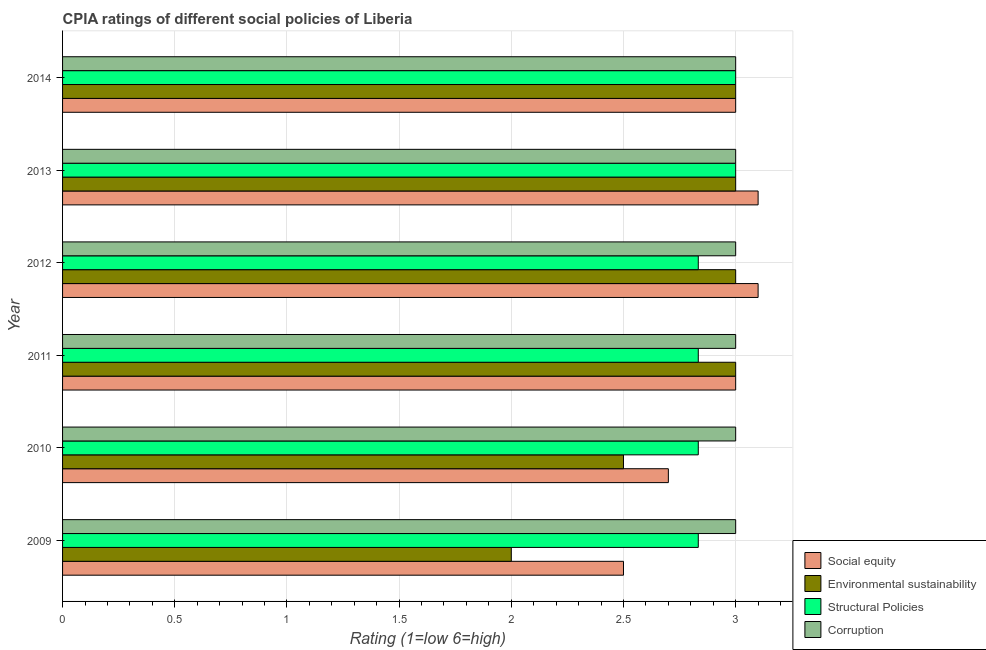How many different coloured bars are there?
Make the answer very short. 4. How many groups of bars are there?
Offer a terse response. 6. Are the number of bars on each tick of the Y-axis equal?
Your answer should be very brief. Yes. How many bars are there on the 6th tick from the top?
Offer a very short reply. 4. In how many cases, is the number of bars for a given year not equal to the number of legend labels?
Ensure brevity in your answer.  0. Across all years, what is the maximum cpia rating of corruption?
Give a very brief answer. 3. Across all years, what is the minimum cpia rating of social equity?
Make the answer very short. 2.5. In which year was the cpia rating of structural policies maximum?
Your answer should be compact. 2013. In which year was the cpia rating of structural policies minimum?
Your answer should be compact. 2009. What is the total cpia rating of structural policies in the graph?
Your response must be concise. 17.33. What is the difference between the cpia rating of structural policies in 2010 and that in 2012?
Provide a succinct answer. 0. What is the difference between the cpia rating of structural policies in 2009 and the cpia rating of corruption in 2011?
Provide a short and direct response. -0.17. What is the average cpia rating of structural policies per year?
Offer a terse response. 2.89. In how many years, is the cpia rating of structural policies greater than 1.5 ?
Provide a short and direct response. 6. Is the cpia rating of corruption in 2010 less than that in 2013?
Your answer should be compact. No. In how many years, is the cpia rating of environmental sustainability greater than the average cpia rating of environmental sustainability taken over all years?
Make the answer very short. 4. Is it the case that in every year, the sum of the cpia rating of social equity and cpia rating of corruption is greater than the sum of cpia rating of structural policies and cpia rating of environmental sustainability?
Your response must be concise. No. What does the 3rd bar from the top in 2011 represents?
Ensure brevity in your answer.  Environmental sustainability. What does the 4th bar from the bottom in 2010 represents?
Ensure brevity in your answer.  Corruption. Is it the case that in every year, the sum of the cpia rating of social equity and cpia rating of environmental sustainability is greater than the cpia rating of structural policies?
Make the answer very short. Yes. How many bars are there?
Keep it short and to the point. 24. What is the difference between two consecutive major ticks on the X-axis?
Offer a very short reply. 0.5. How many legend labels are there?
Your response must be concise. 4. What is the title of the graph?
Your response must be concise. CPIA ratings of different social policies of Liberia. Does "International Monetary Fund" appear as one of the legend labels in the graph?
Your response must be concise. No. What is the Rating (1=low 6=high) of Social equity in 2009?
Provide a short and direct response. 2.5. What is the Rating (1=low 6=high) of Structural Policies in 2009?
Your response must be concise. 2.83. What is the Rating (1=low 6=high) in Social equity in 2010?
Keep it short and to the point. 2.7. What is the Rating (1=low 6=high) of Environmental sustainability in 2010?
Provide a short and direct response. 2.5. What is the Rating (1=low 6=high) of Structural Policies in 2010?
Your response must be concise. 2.83. What is the Rating (1=low 6=high) in Corruption in 2010?
Offer a very short reply. 3. What is the Rating (1=low 6=high) of Environmental sustainability in 2011?
Your response must be concise. 3. What is the Rating (1=low 6=high) of Structural Policies in 2011?
Offer a very short reply. 2.83. What is the Rating (1=low 6=high) in Corruption in 2011?
Keep it short and to the point. 3. What is the Rating (1=low 6=high) of Environmental sustainability in 2012?
Make the answer very short. 3. What is the Rating (1=low 6=high) in Structural Policies in 2012?
Provide a short and direct response. 2.83. What is the Rating (1=low 6=high) in Environmental sustainability in 2013?
Offer a very short reply. 3. What is the Rating (1=low 6=high) in Corruption in 2013?
Ensure brevity in your answer.  3. What is the Rating (1=low 6=high) of Environmental sustainability in 2014?
Give a very brief answer. 3. What is the Rating (1=low 6=high) in Structural Policies in 2014?
Offer a terse response. 3. What is the Rating (1=low 6=high) of Corruption in 2014?
Ensure brevity in your answer.  3. Across all years, what is the maximum Rating (1=low 6=high) in Social equity?
Make the answer very short. 3.1. Across all years, what is the maximum Rating (1=low 6=high) in Structural Policies?
Keep it short and to the point. 3. Across all years, what is the maximum Rating (1=low 6=high) of Corruption?
Give a very brief answer. 3. Across all years, what is the minimum Rating (1=low 6=high) of Social equity?
Make the answer very short. 2.5. Across all years, what is the minimum Rating (1=low 6=high) in Structural Policies?
Provide a short and direct response. 2.83. What is the total Rating (1=low 6=high) in Social equity in the graph?
Give a very brief answer. 17.4. What is the total Rating (1=low 6=high) of Structural Policies in the graph?
Give a very brief answer. 17.33. What is the total Rating (1=low 6=high) of Corruption in the graph?
Your answer should be compact. 18. What is the difference between the Rating (1=low 6=high) of Structural Policies in 2009 and that in 2010?
Your answer should be compact. 0. What is the difference between the Rating (1=low 6=high) in Corruption in 2009 and that in 2010?
Your response must be concise. 0. What is the difference between the Rating (1=low 6=high) of Social equity in 2009 and that in 2011?
Offer a terse response. -0.5. What is the difference between the Rating (1=low 6=high) of Structural Policies in 2009 and that in 2011?
Provide a succinct answer. 0. What is the difference between the Rating (1=low 6=high) in Corruption in 2009 and that in 2011?
Give a very brief answer. 0. What is the difference between the Rating (1=low 6=high) in Social equity in 2009 and that in 2012?
Provide a succinct answer. -0.6. What is the difference between the Rating (1=low 6=high) in Social equity in 2009 and that in 2013?
Offer a very short reply. -0.6. What is the difference between the Rating (1=low 6=high) of Environmental sustainability in 2009 and that in 2013?
Your answer should be compact. -1. What is the difference between the Rating (1=low 6=high) in Corruption in 2009 and that in 2014?
Make the answer very short. 0. What is the difference between the Rating (1=low 6=high) of Environmental sustainability in 2010 and that in 2011?
Keep it short and to the point. -0.5. What is the difference between the Rating (1=low 6=high) in Environmental sustainability in 2010 and that in 2012?
Offer a terse response. -0.5. What is the difference between the Rating (1=low 6=high) in Environmental sustainability in 2010 and that in 2013?
Keep it short and to the point. -0.5. What is the difference between the Rating (1=low 6=high) in Structural Policies in 2010 and that in 2013?
Your answer should be compact. -0.17. What is the difference between the Rating (1=low 6=high) of Corruption in 2010 and that in 2013?
Offer a terse response. 0. What is the difference between the Rating (1=low 6=high) of Environmental sustainability in 2010 and that in 2014?
Your answer should be compact. -0.5. What is the difference between the Rating (1=low 6=high) in Structural Policies in 2010 and that in 2014?
Provide a short and direct response. -0.17. What is the difference between the Rating (1=low 6=high) of Social equity in 2011 and that in 2012?
Give a very brief answer. -0.1. What is the difference between the Rating (1=low 6=high) in Environmental sustainability in 2011 and that in 2012?
Give a very brief answer. 0. What is the difference between the Rating (1=low 6=high) of Structural Policies in 2011 and that in 2012?
Provide a succinct answer. 0. What is the difference between the Rating (1=low 6=high) in Social equity in 2011 and that in 2013?
Offer a very short reply. -0.1. What is the difference between the Rating (1=low 6=high) in Environmental sustainability in 2011 and that in 2013?
Give a very brief answer. 0. What is the difference between the Rating (1=low 6=high) in Corruption in 2011 and that in 2013?
Your answer should be very brief. 0. What is the difference between the Rating (1=low 6=high) of Environmental sustainability in 2011 and that in 2014?
Your answer should be very brief. 0. What is the difference between the Rating (1=low 6=high) of Corruption in 2011 and that in 2014?
Give a very brief answer. 0. What is the difference between the Rating (1=low 6=high) in Environmental sustainability in 2012 and that in 2013?
Provide a short and direct response. 0. What is the difference between the Rating (1=low 6=high) of Structural Policies in 2012 and that in 2013?
Your answer should be very brief. -0.17. What is the difference between the Rating (1=low 6=high) in Social equity in 2012 and that in 2014?
Provide a short and direct response. 0.1. What is the difference between the Rating (1=low 6=high) in Environmental sustainability in 2012 and that in 2014?
Provide a short and direct response. 0. What is the difference between the Rating (1=low 6=high) of Structural Policies in 2013 and that in 2014?
Offer a very short reply. 0. What is the difference between the Rating (1=low 6=high) of Corruption in 2013 and that in 2014?
Your answer should be compact. 0. What is the difference between the Rating (1=low 6=high) in Social equity in 2009 and the Rating (1=low 6=high) in Environmental sustainability in 2010?
Keep it short and to the point. 0. What is the difference between the Rating (1=low 6=high) in Social equity in 2009 and the Rating (1=low 6=high) in Structural Policies in 2010?
Provide a short and direct response. -0.33. What is the difference between the Rating (1=low 6=high) of Environmental sustainability in 2009 and the Rating (1=low 6=high) of Structural Policies in 2010?
Your answer should be very brief. -0.83. What is the difference between the Rating (1=low 6=high) in Environmental sustainability in 2009 and the Rating (1=low 6=high) in Corruption in 2010?
Make the answer very short. -1. What is the difference between the Rating (1=low 6=high) of Structural Policies in 2009 and the Rating (1=low 6=high) of Corruption in 2010?
Make the answer very short. -0.17. What is the difference between the Rating (1=low 6=high) of Environmental sustainability in 2009 and the Rating (1=low 6=high) of Corruption in 2011?
Keep it short and to the point. -1. What is the difference between the Rating (1=low 6=high) in Social equity in 2009 and the Rating (1=low 6=high) in Structural Policies in 2012?
Make the answer very short. -0.33. What is the difference between the Rating (1=low 6=high) of Structural Policies in 2009 and the Rating (1=low 6=high) of Corruption in 2012?
Give a very brief answer. -0.17. What is the difference between the Rating (1=low 6=high) of Social equity in 2009 and the Rating (1=low 6=high) of Environmental sustainability in 2013?
Ensure brevity in your answer.  -0.5. What is the difference between the Rating (1=low 6=high) in Social equity in 2009 and the Rating (1=low 6=high) in Structural Policies in 2013?
Offer a very short reply. -0.5. What is the difference between the Rating (1=low 6=high) of Environmental sustainability in 2009 and the Rating (1=low 6=high) of Structural Policies in 2013?
Provide a short and direct response. -1. What is the difference between the Rating (1=low 6=high) of Social equity in 2009 and the Rating (1=low 6=high) of Environmental sustainability in 2014?
Keep it short and to the point. -0.5. What is the difference between the Rating (1=low 6=high) in Environmental sustainability in 2009 and the Rating (1=low 6=high) in Structural Policies in 2014?
Make the answer very short. -1. What is the difference between the Rating (1=low 6=high) of Structural Policies in 2009 and the Rating (1=low 6=high) of Corruption in 2014?
Offer a terse response. -0.17. What is the difference between the Rating (1=low 6=high) in Social equity in 2010 and the Rating (1=low 6=high) in Environmental sustainability in 2011?
Provide a succinct answer. -0.3. What is the difference between the Rating (1=low 6=high) of Social equity in 2010 and the Rating (1=low 6=high) of Structural Policies in 2011?
Your response must be concise. -0.13. What is the difference between the Rating (1=low 6=high) in Social equity in 2010 and the Rating (1=low 6=high) in Corruption in 2011?
Offer a very short reply. -0.3. What is the difference between the Rating (1=low 6=high) in Environmental sustainability in 2010 and the Rating (1=low 6=high) in Structural Policies in 2011?
Give a very brief answer. -0.33. What is the difference between the Rating (1=low 6=high) in Social equity in 2010 and the Rating (1=low 6=high) in Environmental sustainability in 2012?
Give a very brief answer. -0.3. What is the difference between the Rating (1=low 6=high) of Social equity in 2010 and the Rating (1=low 6=high) of Structural Policies in 2012?
Make the answer very short. -0.13. What is the difference between the Rating (1=low 6=high) of Environmental sustainability in 2010 and the Rating (1=low 6=high) of Structural Policies in 2013?
Provide a succinct answer. -0.5. What is the difference between the Rating (1=low 6=high) of Social equity in 2010 and the Rating (1=low 6=high) of Environmental sustainability in 2014?
Give a very brief answer. -0.3. What is the difference between the Rating (1=low 6=high) in Social equity in 2010 and the Rating (1=low 6=high) in Structural Policies in 2014?
Provide a short and direct response. -0.3. What is the difference between the Rating (1=low 6=high) of Social equity in 2010 and the Rating (1=low 6=high) of Corruption in 2014?
Your response must be concise. -0.3. What is the difference between the Rating (1=low 6=high) in Environmental sustainability in 2010 and the Rating (1=low 6=high) in Corruption in 2014?
Offer a very short reply. -0.5. What is the difference between the Rating (1=low 6=high) in Structural Policies in 2010 and the Rating (1=low 6=high) in Corruption in 2014?
Give a very brief answer. -0.17. What is the difference between the Rating (1=low 6=high) of Social equity in 2011 and the Rating (1=low 6=high) of Structural Policies in 2012?
Your answer should be compact. 0.17. What is the difference between the Rating (1=low 6=high) in Social equity in 2011 and the Rating (1=low 6=high) in Corruption in 2012?
Provide a succinct answer. 0. What is the difference between the Rating (1=low 6=high) of Environmental sustainability in 2011 and the Rating (1=low 6=high) of Corruption in 2012?
Your answer should be compact. 0. What is the difference between the Rating (1=low 6=high) of Structural Policies in 2011 and the Rating (1=low 6=high) of Corruption in 2012?
Provide a short and direct response. -0.17. What is the difference between the Rating (1=low 6=high) in Social equity in 2011 and the Rating (1=low 6=high) in Environmental sustainability in 2013?
Your response must be concise. 0. What is the difference between the Rating (1=low 6=high) in Social equity in 2011 and the Rating (1=low 6=high) in Structural Policies in 2013?
Provide a succinct answer. 0. What is the difference between the Rating (1=low 6=high) of Environmental sustainability in 2011 and the Rating (1=low 6=high) of Structural Policies in 2013?
Your answer should be compact. 0. What is the difference between the Rating (1=low 6=high) in Social equity in 2011 and the Rating (1=low 6=high) in Corruption in 2014?
Provide a succinct answer. 0. What is the difference between the Rating (1=low 6=high) in Environmental sustainability in 2011 and the Rating (1=low 6=high) in Structural Policies in 2014?
Ensure brevity in your answer.  0. What is the difference between the Rating (1=low 6=high) of Social equity in 2012 and the Rating (1=low 6=high) of Corruption in 2013?
Your answer should be compact. 0.1. What is the difference between the Rating (1=low 6=high) in Structural Policies in 2012 and the Rating (1=low 6=high) in Corruption in 2013?
Provide a succinct answer. -0.17. What is the difference between the Rating (1=low 6=high) in Social equity in 2012 and the Rating (1=low 6=high) in Environmental sustainability in 2014?
Make the answer very short. 0.1. What is the difference between the Rating (1=low 6=high) in Social equity in 2012 and the Rating (1=low 6=high) in Structural Policies in 2014?
Your answer should be compact. 0.1. What is the difference between the Rating (1=low 6=high) of Social equity in 2012 and the Rating (1=low 6=high) of Corruption in 2014?
Your answer should be very brief. 0.1. What is the difference between the Rating (1=low 6=high) in Environmental sustainability in 2012 and the Rating (1=low 6=high) in Structural Policies in 2014?
Give a very brief answer. 0. What is the difference between the Rating (1=low 6=high) of Environmental sustainability in 2012 and the Rating (1=low 6=high) of Corruption in 2014?
Give a very brief answer. 0. What is the difference between the Rating (1=low 6=high) in Environmental sustainability in 2013 and the Rating (1=low 6=high) in Structural Policies in 2014?
Ensure brevity in your answer.  0. What is the difference between the Rating (1=low 6=high) of Structural Policies in 2013 and the Rating (1=low 6=high) of Corruption in 2014?
Provide a succinct answer. 0. What is the average Rating (1=low 6=high) of Social equity per year?
Give a very brief answer. 2.9. What is the average Rating (1=low 6=high) of Environmental sustainability per year?
Make the answer very short. 2.75. What is the average Rating (1=low 6=high) in Structural Policies per year?
Provide a short and direct response. 2.89. What is the average Rating (1=low 6=high) in Corruption per year?
Ensure brevity in your answer.  3. In the year 2009, what is the difference between the Rating (1=low 6=high) in Social equity and Rating (1=low 6=high) in Environmental sustainability?
Offer a terse response. 0.5. In the year 2009, what is the difference between the Rating (1=low 6=high) of Social equity and Rating (1=low 6=high) of Corruption?
Offer a very short reply. -0.5. In the year 2009, what is the difference between the Rating (1=low 6=high) in Environmental sustainability and Rating (1=low 6=high) in Corruption?
Your answer should be compact. -1. In the year 2009, what is the difference between the Rating (1=low 6=high) of Structural Policies and Rating (1=low 6=high) of Corruption?
Keep it short and to the point. -0.17. In the year 2010, what is the difference between the Rating (1=low 6=high) in Social equity and Rating (1=low 6=high) in Environmental sustainability?
Offer a very short reply. 0.2. In the year 2010, what is the difference between the Rating (1=low 6=high) of Social equity and Rating (1=low 6=high) of Structural Policies?
Ensure brevity in your answer.  -0.13. In the year 2010, what is the difference between the Rating (1=low 6=high) in Social equity and Rating (1=low 6=high) in Corruption?
Provide a short and direct response. -0.3. In the year 2010, what is the difference between the Rating (1=low 6=high) of Structural Policies and Rating (1=low 6=high) of Corruption?
Provide a succinct answer. -0.17. In the year 2011, what is the difference between the Rating (1=low 6=high) of Social equity and Rating (1=low 6=high) of Environmental sustainability?
Make the answer very short. 0. In the year 2011, what is the difference between the Rating (1=low 6=high) of Environmental sustainability and Rating (1=low 6=high) of Structural Policies?
Your response must be concise. 0.17. In the year 2011, what is the difference between the Rating (1=low 6=high) in Structural Policies and Rating (1=low 6=high) in Corruption?
Give a very brief answer. -0.17. In the year 2012, what is the difference between the Rating (1=low 6=high) in Social equity and Rating (1=low 6=high) in Environmental sustainability?
Your response must be concise. 0.1. In the year 2012, what is the difference between the Rating (1=low 6=high) in Social equity and Rating (1=low 6=high) in Structural Policies?
Provide a short and direct response. 0.27. In the year 2012, what is the difference between the Rating (1=low 6=high) in Social equity and Rating (1=low 6=high) in Corruption?
Make the answer very short. 0.1. In the year 2012, what is the difference between the Rating (1=low 6=high) of Environmental sustainability and Rating (1=low 6=high) of Structural Policies?
Offer a very short reply. 0.17. In the year 2012, what is the difference between the Rating (1=low 6=high) of Environmental sustainability and Rating (1=low 6=high) of Corruption?
Your answer should be compact. 0. In the year 2012, what is the difference between the Rating (1=low 6=high) of Structural Policies and Rating (1=low 6=high) of Corruption?
Offer a terse response. -0.17. In the year 2013, what is the difference between the Rating (1=low 6=high) of Environmental sustainability and Rating (1=low 6=high) of Structural Policies?
Provide a short and direct response. 0. In the year 2013, what is the difference between the Rating (1=low 6=high) of Environmental sustainability and Rating (1=low 6=high) of Corruption?
Provide a succinct answer. 0. In the year 2013, what is the difference between the Rating (1=low 6=high) in Structural Policies and Rating (1=low 6=high) in Corruption?
Ensure brevity in your answer.  0. In the year 2014, what is the difference between the Rating (1=low 6=high) of Social equity and Rating (1=low 6=high) of Environmental sustainability?
Provide a succinct answer. 0. In the year 2014, what is the difference between the Rating (1=low 6=high) in Structural Policies and Rating (1=low 6=high) in Corruption?
Provide a succinct answer. 0. What is the ratio of the Rating (1=low 6=high) in Social equity in 2009 to that in 2010?
Ensure brevity in your answer.  0.93. What is the ratio of the Rating (1=low 6=high) in Social equity in 2009 to that in 2011?
Ensure brevity in your answer.  0.83. What is the ratio of the Rating (1=low 6=high) of Corruption in 2009 to that in 2011?
Keep it short and to the point. 1. What is the ratio of the Rating (1=low 6=high) in Social equity in 2009 to that in 2012?
Give a very brief answer. 0.81. What is the ratio of the Rating (1=low 6=high) of Structural Policies in 2009 to that in 2012?
Provide a short and direct response. 1. What is the ratio of the Rating (1=low 6=high) in Social equity in 2009 to that in 2013?
Ensure brevity in your answer.  0.81. What is the ratio of the Rating (1=low 6=high) in Environmental sustainability in 2009 to that in 2013?
Provide a succinct answer. 0.67. What is the ratio of the Rating (1=low 6=high) of Corruption in 2009 to that in 2013?
Provide a succinct answer. 1. What is the ratio of the Rating (1=low 6=high) of Social equity in 2009 to that in 2014?
Give a very brief answer. 0.83. What is the ratio of the Rating (1=low 6=high) of Corruption in 2009 to that in 2014?
Ensure brevity in your answer.  1. What is the ratio of the Rating (1=low 6=high) of Social equity in 2010 to that in 2011?
Ensure brevity in your answer.  0.9. What is the ratio of the Rating (1=low 6=high) of Environmental sustainability in 2010 to that in 2011?
Keep it short and to the point. 0.83. What is the ratio of the Rating (1=low 6=high) in Corruption in 2010 to that in 2011?
Offer a terse response. 1. What is the ratio of the Rating (1=low 6=high) of Social equity in 2010 to that in 2012?
Offer a terse response. 0.87. What is the ratio of the Rating (1=low 6=high) of Environmental sustainability in 2010 to that in 2012?
Keep it short and to the point. 0.83. What is the ratio of the Rating (1=low 6=high) of Structural Policies in 2010 to that in 2012?
Your answer should be compact. 1. What is the ratio of the Rating (1=low 6=high) in Corruption in 2010 to that in 2012?
Make the answer very short. 1. What is the ratio of the Rating (1=low 6=high) of Social equity in 2010 to that in 2013?
Provide a succinct answer. 0.87. What is the ratio of the Rating (1=low 6=high) of Environmental sustainability in 2010 to that in 2013?
Provide a succinct answer. 0.83. What is the ratio of the Rating (1=low 6=high) in Social equity in 2010 to that in 2014?
Offer a terse response. 0.9. What is the ratio of the Rating (1=low 6=high) in Structural Policies in 2010 to that in 2014?
Make the answer very short. 0.94. What is the ratio of the Rating (1=low 6=high) in Corruption in 2010 to that in 2014?
Your answer should be compact. 1. What is the ratio of the Rating (1=low 6=high) of Social equity in 2011 to that in 2012?
Your response must be concise. 0.97. What is the ratio of the Rating (1=low 6=high) of Corruption in 2011 to that in 2012?
Offer a very short reply. 1. What is the ratio of the Rating (1=low 6=high) in Social equity in 2011 to that in 2013?
Provide a succinct answer. 0.97. What is the ratio of the Rating (1=low 6=high) in Corruption in 2011 to that in 2013?
Give a very brief answer. 1. What is the ratio of the Rating (1=low 6=high) in Structural Policies in 2011 to that in 2014?
Your response must be concise. 0.94. What is the ratio of the Rating (1=low 6=high) of Corruption in 2011 to that in 2014?
Your answer should be very brief. 1. What is the ratio of the Rating (1=low 6=high) in Social equity in 2012 to that in 2013?
Ensure brevity in your answer.  1. What is the ratio of the Rating (1=low 6=high) in Structural Policies in 2012 to that in 2013?
Ensure brevity in your answer.  0.94. What is the ratio of the Rating (1=low 6=high) in Corruption in 2012 to that in 2013?
Provide a succinct answer. 1. What is the ratio of the Rating (1=low 6=high) in Social equity in 2012 to that in 2014?
Offer a terse response. 1.03. What is the ratio of the Rating (1=low 6=high) in Environmental sustainability in 2012 to that in 2014?
Offer a very short reply. 1. What is the ratio of the Rating (1=low 6=high) in Structural Policies in 2012 to that in 2014?
Give a very brief answer. 0.94. What is the ratio of the Rating (1=low 6=high) of Environmental sustainability in 2013 to that in 2014?
Offer a terse response. 1. What is the ratio of the Rating (1=low 6=high) of Corruption in 2013 to that in 2014?
Offer a terse response. 1. What is the difference between the highest and the second highest Rating (1=low 6=high) of Corruption?
Provide a succinct answer. 0. What is the difference between the highest and the lowest Rating (1=low 6=high) of Social equity?
Offer a very short reply. 0.6. What is the difference between the highest and the lowest Rating (1=low 6=high) in Structural Policies?
Keep it short and to the point. 0.17. What is the difference between the highest and the lowest Rating (1=low 6=high) of Corruption?
Your response must be concise. 0. 